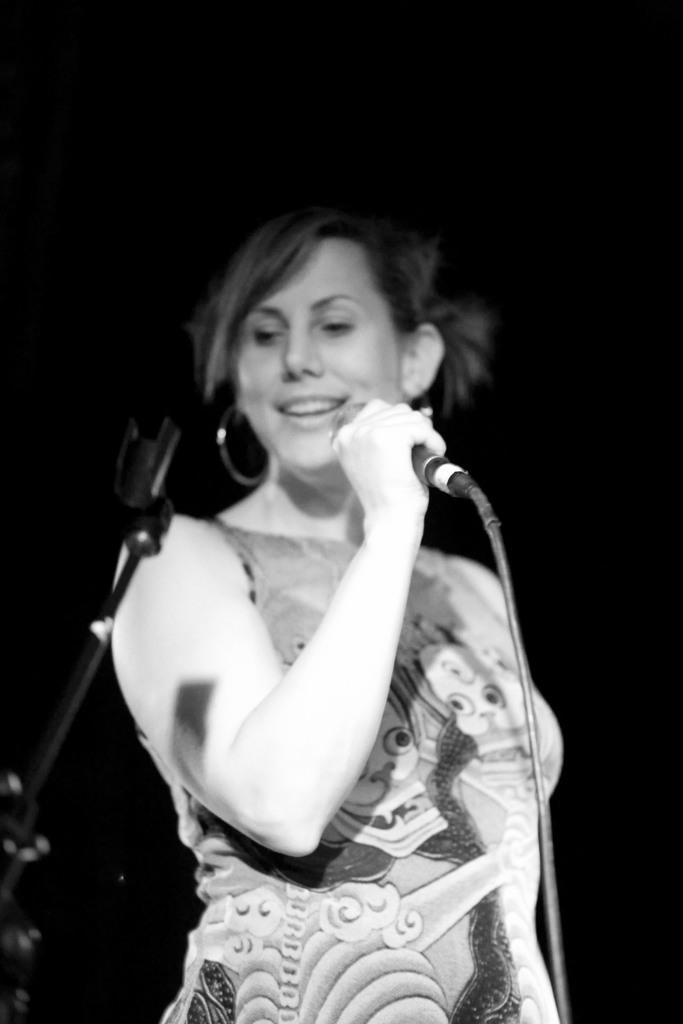What is the color scheme of the image? The image is black and white. What is the woman in the image doing? The woman is standing and holding a microphone. Is there any equipment related to the microphone visible in the image? Yes, there is a microphone stand to the left of the woman. How would you describe the background of the image? The background behind the woman is dark. How many hours does the woman sleep in the image? The image does not provide any information about the woman's sleeping habits, so we cannot determine how many hours she sleeps. What type of noise can be heard in the image? The image is a still image, so there is no sound or noise present. 